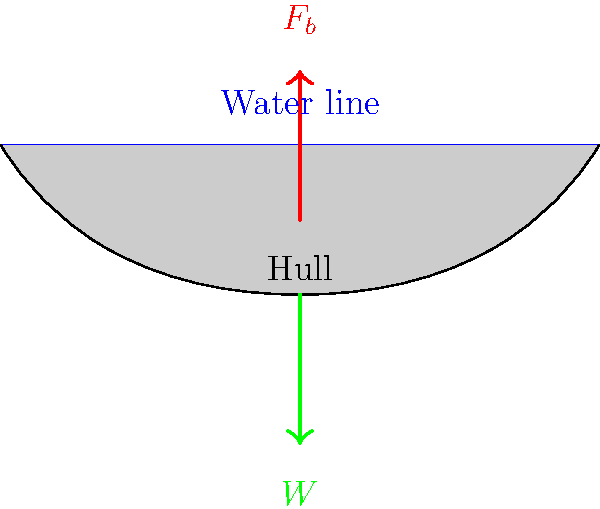As a fisherman who takes football players on team-building fishing trips, you're designing a new boat for your excursions. The boat has a hull shape as shown in the diagram. If the boat has a weight ($W$) of 5000 N and displaces 0.5 m³ of water, what is the buoyancy force ($F_b$) acting on the boat? Assume the density of water is 1000 kg/m³ and $g = 9.81$ m/s². To solve this problem, we'll use Archimedes' principle, which states that the buoyancy force is equal to the weight of the fluid displaced. Let's follow these steps:

1) First, recall the formula for buoyancy force:
   $F_b = \rho_{water} \cdot V_{displaced} \cdot g$

   Where:
   $F_b$ is the buoyancy force
   $\rho_{water}$ is the density of water
   $V_{displaced}$ is the volume of water displaced
   $g$ is the acceleration due to gravity

2) We're given:
   $\rho_{water} = 1000$ kg/m³
   $V_{displaced} = 0.5$ m³
   $g = 9.81$ m/s²

3) Let's substitute these values into our equation:
   $F_b = 1000 \text{ kg/m³} \cdot 0.5 \text{ m³} \cdot 9.81 \text{ m/s²}$

4) Now we can calculate:
   $F_b = 4905 \text{ N}$

5) We can round this to 4900 N for simplicity.

6) To verify, we can check if this makes sense with the given weight of the boat (5000 N). The buoyancy force should be close to, but slightly less than the weight of the boat for it to float while being partially submerged.

Therefore, the buoyancy force acting on the boat is approximately 4900 N.
Answer: 4900 N 